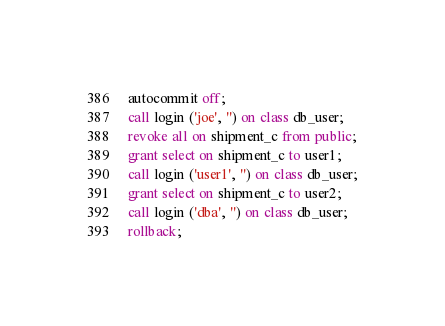Convert code to text. <code><loc_0><loc_0><loc_500><loc_500><_SQL_>autocommit off;
call login ('joe', '') on class db_user;
revoke all on shipment_c from public;
grant select on shipment_c to user1;
call login ('user1', '') on class db_user;
grant select on shipment_c to user2;
call login ('dba', '') on class db_user;
rollback;
</code> 